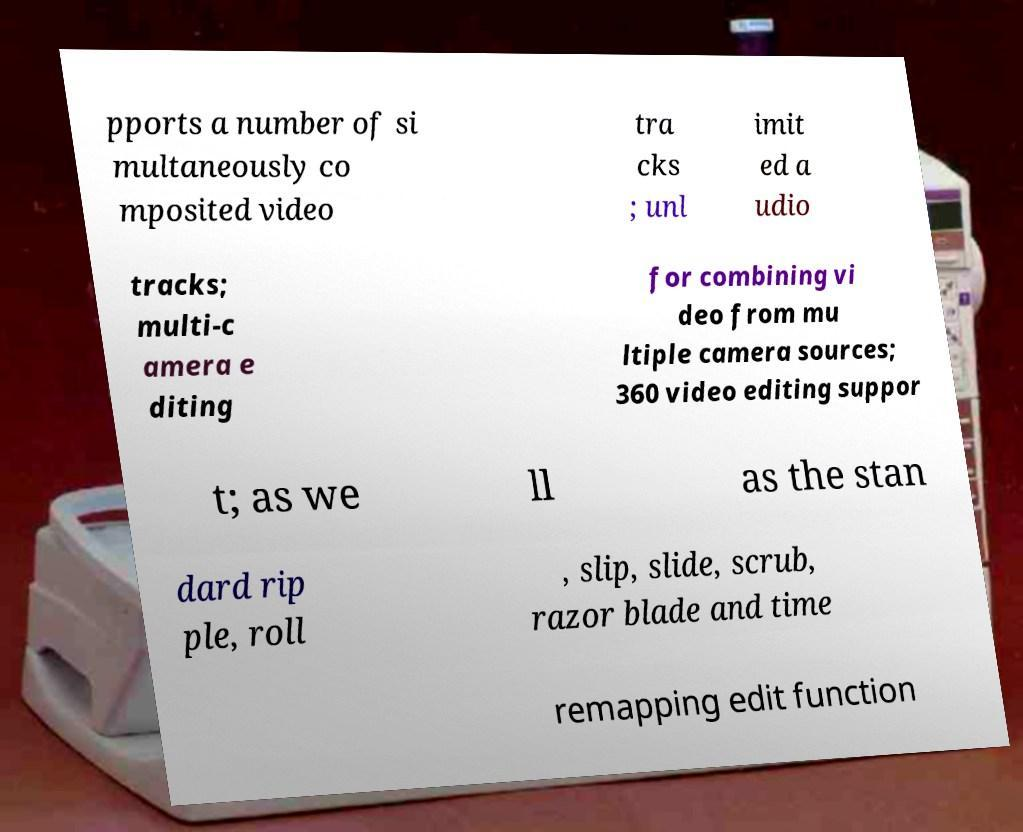There's text embedded in this image that I need extracted. Can you transcribe it verbatim? pports a number of si multaneously co mposited video tra cks ; unl imit ed a udio tracks; multi-c amera e diting for combining vi deo from mu ltiple camera sources; 360 video editing suppor t; as we ll as the stan dard rip ple, roll , slip, slide, scrub, razor blade and time remapping edit function 